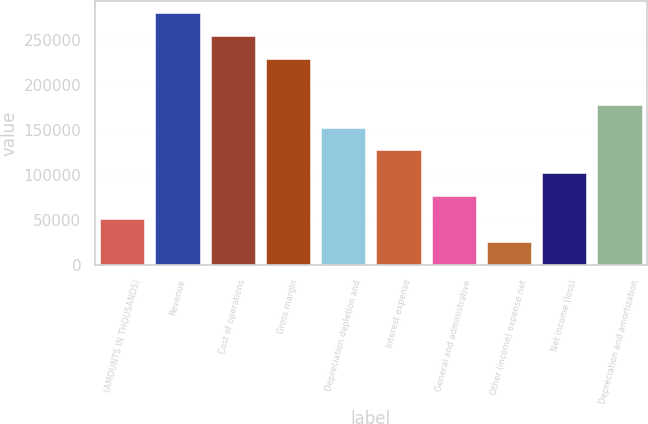Convert chart to OTSL. <chart><loc_0><loc_0><loc_500><loc_500><bar_chart><fcel>(AMOUNTS IN THOUSANDS)<fcel>Revenue<fcel>Cost of operations<fcel>Gross margin<fcel>Depreciation depletion and<fcel>Interest expense<fcel>General and administrative<fcel>Other (income) expense net<fcel>Net income (loss)<fcel>Depreciation and amortization<nl><fcel>51119.8<fcel>279345<fcel>253987<fcel>228629<fcel>152553<fcel>127195<fcel>76478.2<fcel>25761.4<fcel>101837<fcel>177912<nl></chart> 